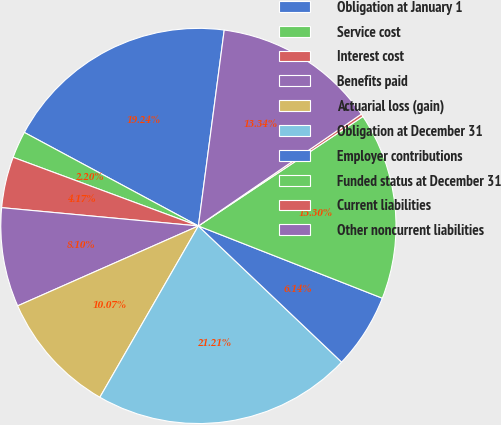Convert chart. <chart><loc_0><loc_0><loc_500><loc_500><pie_chart><fcel>Obligation at January 1<fcel>Service cost<fcel>Interest cost<fcel>Benefits paid<fcel>Actuarial loss (gain)<fcel>Obligation at December 31<fcel>Employer contributions<fcel>Funded status at December 31<fcel>Current liabilities<fcel>Other noncurrent liabilities<nl><fcel>19.24%<fcel>2.2%<fcel>4.17%<fcel>8.1%<fcel>10.07%<fcel>21.21%<fcel>6.14%<fcel>15.3%<fcel>0.23%<fcel>13.34%<nl></chart> 